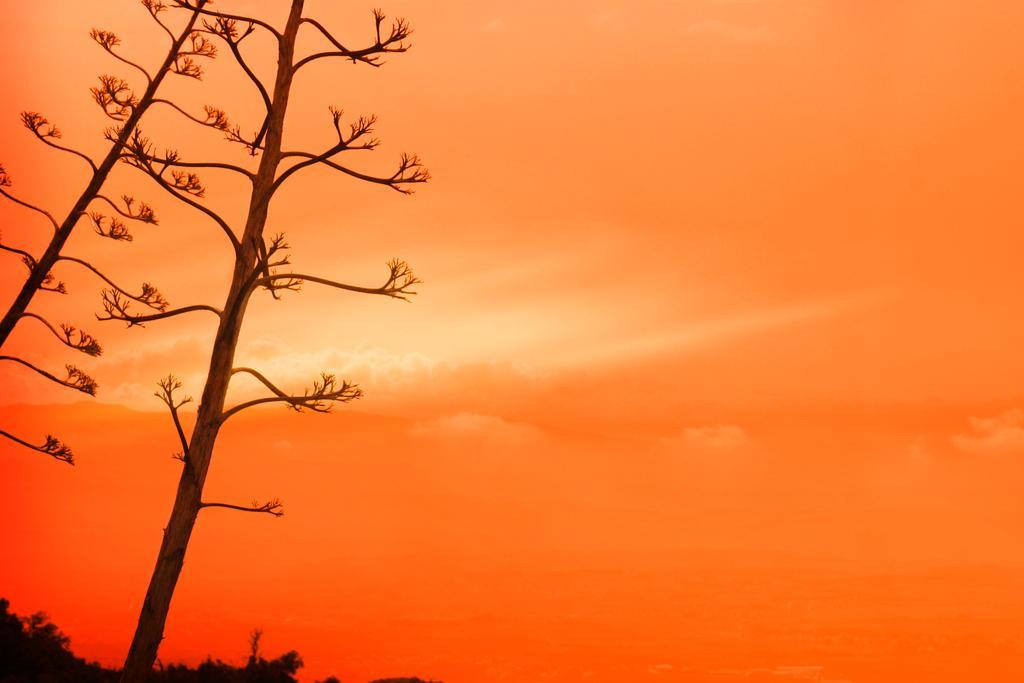Please provide a concise description of this image. In the left side of the image there are some trees. In the middle of the image there are some clouds and sky. 